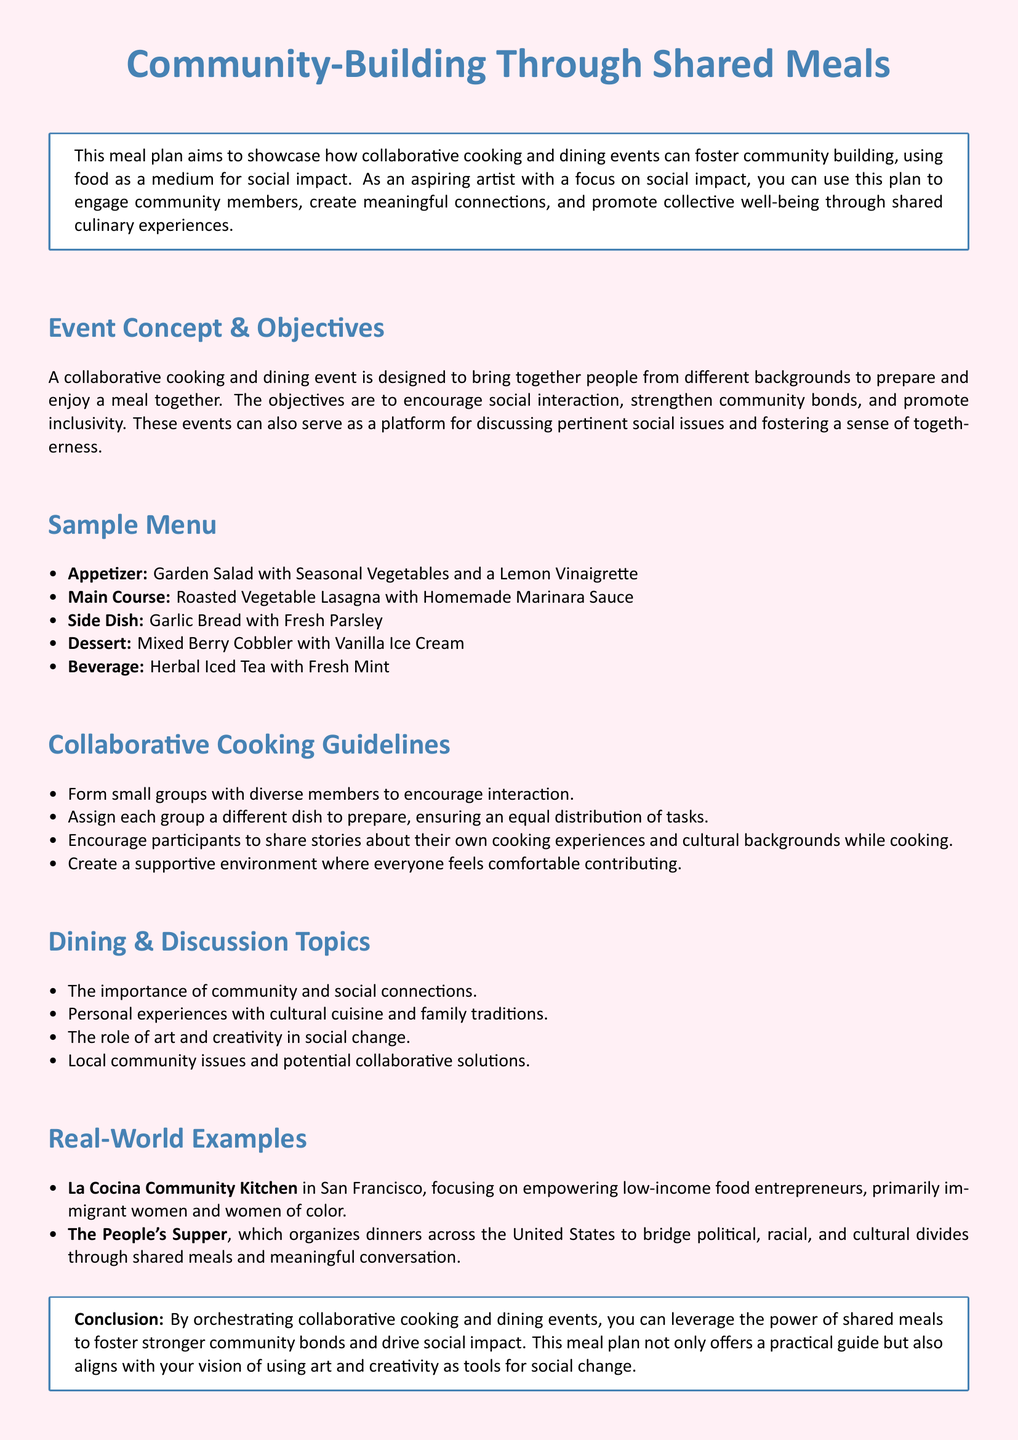What is the main goal of the meal plan? The main goal of the meal plan is to showcase how collaborative cooking and dining events can foster community building.
Answer: community building What is the appetizer in the sample menu? The appetizer listed in the sample menu is a Garden Salad with Seasonal Vegetables and a Lemon Vinaigrette.
Answer: Garden Salad What types of beverages are included? The beverage included in the sample menu is Herbal Iced Tea with Fresh Mint.
Answer: Herbal Iced Tea How many real-world examples are provided? There are two real-world examples provided in the document.
Answer: 2 What is one of the dining discussion topics? One of the dining discussion topics is the importance of community and social connections.
Answer: importance of community What is a key aspect of the collaborative cooking guidelines? A key aspect is to form small groups with diverse members to encourage interaction.
Answer: diverse members Which community kitchen focuses on empowering low-income food entrepreneurs? The community kitchen that focuses on this is La Cocina Community Kitchen in San Francisco.
Answer: La Cocina Community Kitchen How does the meal plan align with the vision of the artist? The meal plan aligns with the vision by using art and creativity as tools for social change.
Answer: social change 